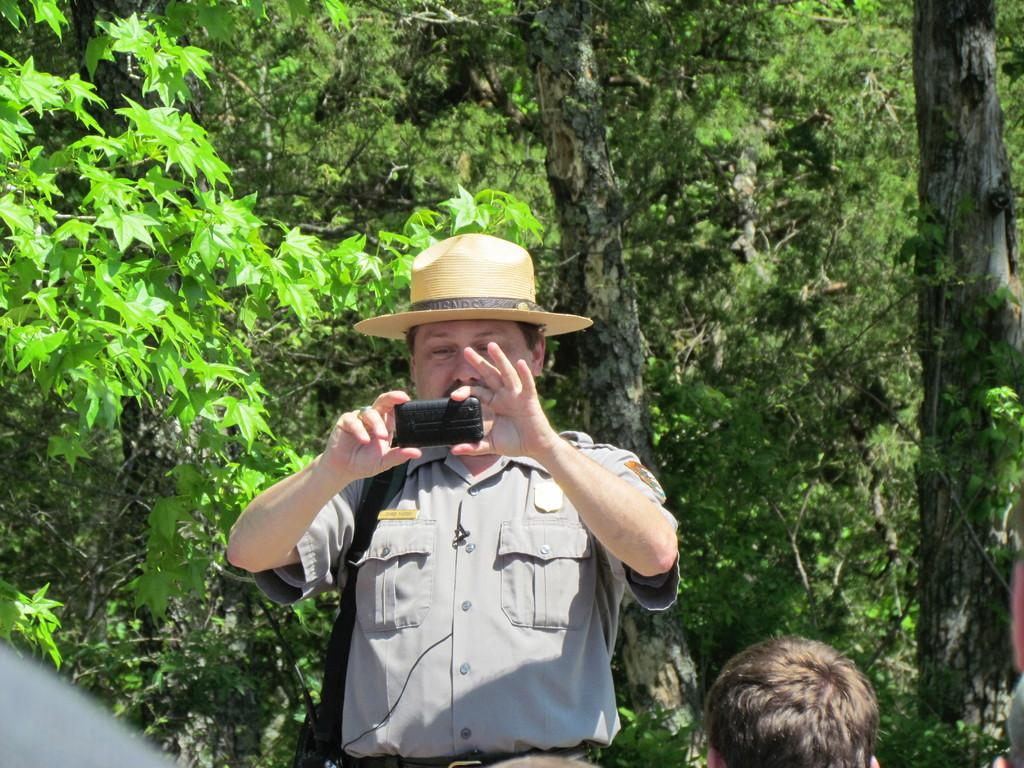What is the main subject of the image? There is a man standing in the center of the image. What is the man holding in his hand? The man is holding a mobile in his hand. Can you describe the man's attire? The man is wearing a hat. Who else is present in the image? There is a person at the bottom of the image. What can be seen in the background of the image? There are trees in the background of the image. What type of ring can be seen on the man's finger in the image? There is no ring visible on the man's finger in the image. What books can be found in the library depicted in the image? There is no library present in the image. 